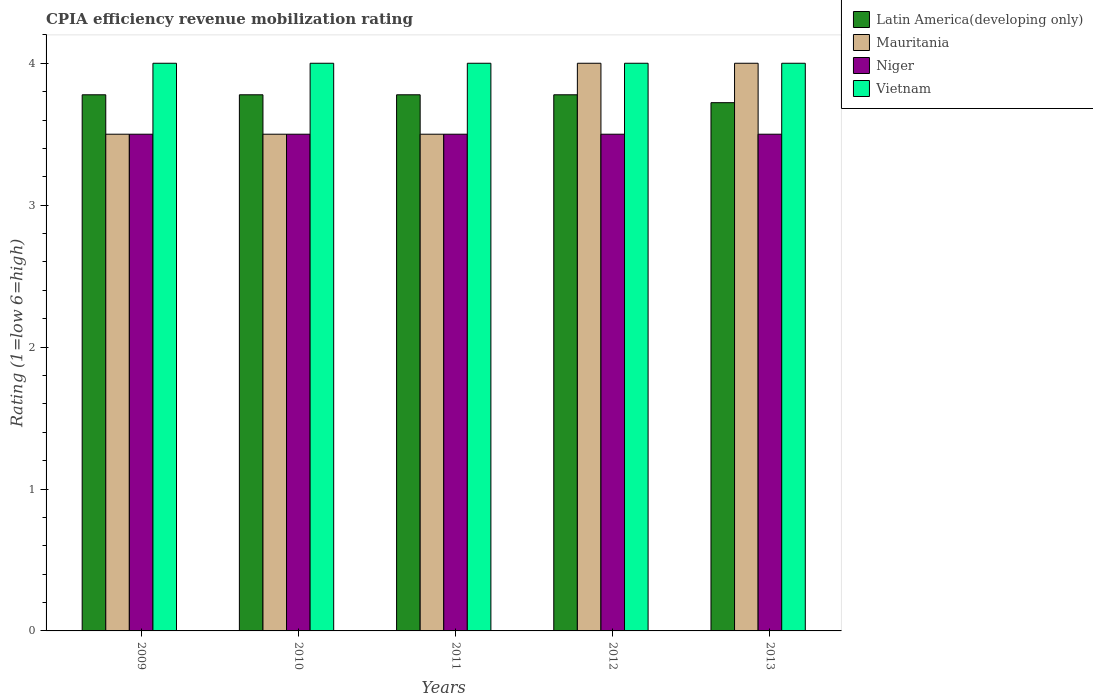How many groups of bars are there?
Your answer should be compact. 5. Are the number of bars on each tick of the X-axis equal?
Offer a terse response. Yes. How many bars are there on the 4th tick from the right?
Give a very brief answer. 4. What is the label of the 1st group of bars from the left?
Give a very brief answer. 2009. In how many cases, is the number of bars for a given year not equal to the number of legend labels?
Provide a succinct answer. 0. What is the CPIA rating in Niger in 2013?
Provide a succinct answer. 3.5. Across all years, what is the maximum CPIA rating in Vietnam?
Offer a terse response. 4. Across all years, what is the minimum CPIA rating in Latin America(developing only)?
Offer a very short reply. 3.72. In which year was the CPIA rating in Mauritania maximum?
Keep it short and to the point. 2012. What is the average CPIA rating in Latin America(developing only) per year?
Provide a short and direct response. 3.77. In the year 2010, what is the difference between the CPIA rating in Mauritania and CPIA rating in Latin America(developing only)?
Offer a terse response. -0.28. What is the ratio of the CPIA rating in Niger in 2009 to that in 2011?
Give a very brief answer. 1. Is the difference between the CPIA rating in Mauritania in 2010 and 2011 greater than the difference between the CPIA rating in Latin America(developing only) in 2010 and 2011?
Keep it short and to the point. No. Is the sum of the CPIA rating in Latin America(developing only) in 2010 and 2012 greater than the maximum CPIA rating in Mauritania across all years?
Ensure brevity in your answer.  Yes. What does the 1st bar from the left in 2013 represents?
Your answer should be very brief. Latin America(developing only). What does the 3rd bar from the right in 2011 represents?
Give a very brief answer. Mauritania. Is it the case that in every year, the sum of the CPIA rating in Latin America(developing only) and CPIA rating in Mauritania is greater than the CPIA rating in Vietnam?
Your answer should be compact. Yes. Are all the bars in the graph horizontal?
Your answer should be compact. No. Where does the legend appear in the graph?
Keep it short and to the point. Top right. What is the title of the graph?
Offer a terse response. CPIA efficiency revenue mobilization rating. Does "Cambodia" appear as one of the legend labels in the graph?
Your answer should be very brief. No. What is the label or title of the X-axis?
Your answer should be very brief. Years. What is the label or title of the Y-axis?
Make the answer very short. Rating (1=low 6=high). What is the Rating (1=low 6=high) in Latin America(developing only) in 2009?
Ensure brevity in your answer.  3.78. What is the Rating (1=low 6=high) of Mauritania in 2009?
Keep it short and to the point. 3.5. What is the Rating (1=low 6=high) of Latin America(developing only) in 2010?
Make the answer very short. 3.78. What is the Rating (1=low 6=high) in Mauritania in 2010?
Offer a very short reply. 3.5. What is the Rating (1=low 6=high) in Latin America(developing only) in 2011?
Give a very brief answer. 3.78. What is the Rating (1=low 6=high) of Vietnam in 2011?
Offer a very short reply. 4. What is the Rating (1=low 6=high) in Latin America(developing only) in 2012?
Offer a terse response. 3.78. What is the Rating (1=low 6=high) of Mauritania in 2012?
Give a very brief answer. 4. What is the Rating (1=low 6=high) in Niger in 2012?
Offer a terse response. 3.5. What is the Rating (1=low 6=high) in Vietnam in 2012?
Provide a short and direct response. 4. What is the Rating (1=low 6=high) of Latin America(developing only) in 2013?
Offer a terse response. 3.72. What is the Rating (1=low 6=high) in Mauritania in 2013?
Make the answer very short. 4. What is the Rating (1=low 6=high) of Vietnam in 2013?
Offer a terse response. 4. Across all years, what is the maximum Rating (1=low 6=high) of Latin America(developing only)?
Your answer should be compact. 3.78. Across all years, what is the maximum Rating (1=low 6=high) in Mauritania?
Ensure brevity in your answer.  4. Across all years, what is the maximum Rating (1=low 6=high) of Niger?
Your answer should be very brief. 3.5. Across all years, what is the maximum Rating (1=low 6=high) of Vietnam?
Keep it short and to the point. 4. Across all years, what is the minimum Rating (1=low 6=high) in Latin America(developing only)?
Give a very brief answer. 3.72. Across all years, what is the minimum Rating (1=low 6=high) in Niger?
Offer a very short reply. 3.5. Across all years, what is the minimum Rating (1=low 6=high) of Vietnam?
Your answer should be compact. 4. What is the total Rating (1=low 6=high) in Latin America(developing only) in the graph?
Your answer should be very brief. 18.83. What is the total Rating (1=low 6=high) in Mauritania in the graph?
Provide a succinct answer. 18.5. What is the total Rating (1=low 6=high) in Niger in the graph?
Your answer should be compact. 17.5. What is the total Rating (1=low 6=high) in Vietnam in the graph?
Keep it short and to the point. 20. What is the difference between the Rating (1=low 6=high) of Mauritania in 2009 and that in 2010?
Keep it short and to the point. 0. What is the difference between the Rating (1=low 6=high) of Vietnam in 2009 and that in 2010?
Offer a terse response. 0. What is the difference between the Rating (1=low 6=high) in Mauritania in 2009 and that in 2012?
Offer a very short reply. -0.5. What is the difference between the Rating (1=low 6=high) of Niger in 2009 and that in 2012?
Your answer should be compact. 0. What is the difference between the Rating (1=low 6=high) in Latin America(developing only) in 2009 and that in 2013?
Offer a very short reply. 0.06. What is the difference between the Rating (1=low 6=high) in Latin America(developing only) in 2010 and that in 2011?
Offer a terse response. 0. What is the difference between the Rating (1=low 6=high) of Niger in 2010 and that in 2011?
Make the answer very short. 0. What is the difference between the Rating (1=low 6=high) of Mauritania in 2010 and that in 2012?
Make the answer very short. -0.5. What is the difference between the Rating (1=low 6=high) of Niger in 2010 and that in 2012?
Ensure brevity in your answer.  0. What is the difference between the Rating (1=low 6=high) in Vietnam in 2010 and that in 2012?
Your answer should be very brief. 0. What is the difference between the Rating (1=low 6=high) of Latin America(developing only) in 2010 and that in 2013?
Provide a succinct answer. 0.06. What is the difference between the Rating (1=low 6=high) of Vietnam in 2010 and that in 2013?
Provide a succinct answer. 0. What is the difference between the Rating (1=low 6=high) of Mauritania in 2011 and that in 2012?
Keep it short and to the point. -0.5. What is the difference between the Rating (1=low 6=high) of Vietnam in 2011 and that in 2012?
Your answer should be very brief. 0. What is the difference between the Rating (1=low 6=high) in Latin America(developing only) in 2011 and that in 2013?
Give a very brief answer. 0.06. What is the difference between the Rating (1=low 6=high) in Niger in 2011 and that in 2013?
Provide a succinct answer. 0. What is the difference between the Rating (1=low 6=high) of Latin America(developing only) in 2012 and that in 2013?
Your answer should be very brief. 0.06. What is the difference between the Rating (1=low 6=high) of Niger in 2012 and that in 2013?
Make the answer very short. 0. What is the difference between the Rating (1=low 6=high) of Latin America(developing only) in 2009 and the Rating (1=low 6=high) of Mauritania in 2010?
Keep it short and to the point. 0.28. What is the difference between the Rating (1=low 6=high) of Latin America(developing only) in 2009 and the Rating (1=low 6=high) of Niger in 2010?
Your response must be concise. 0.28. What is the difference between the Rating (1=low 6=high) in Latin America(developing only) in 2009 and the Rating (1=low 6=high) in Vietnam in 2010?
Offer a terse response. -0.22. What is the difference between the Rating (1=low 6=high) of Mauritania in 2009 and the Rating (1=low 6=high) of Vietnam in 2010?
Your answer should be compact. -0.5. What is the difference between the Rating (1=low 6=high) of Niger in 2009 and the Rating (1=low 6=high) of Vietnam in 2010?
Keep it short and to the point. -0.5. What is the difference between the Rating (1=low 6=high) in Latin America(developing only) in 2009 and the Rating (1=low 6=high) in Mauritania in 2011?
Keep it short and to the point. 0.28. What is the difference between the Rating (1=low 6=high) of Latin America(developing only) in 2009 and the Rating (1=low 6=high) of Niger in 2011?
Give a very brief answer. 0.28. What is the difference between the Rating (1=low 6=high) of Latin America(developing only) in 2009 and the Rating (1=low 6=high) of Vietnam in 2011?
Make the answer very short. -0.22. What is the difference between the Rating (1=low 6=high) in Niger in 2009 and the Rating (1=low 6=high) in Vietnam in 2011?
Your answer should be compact. -0.5. What is the difference between the Rating (1=low 6=high) in Latin America(developing only) in 2009 and the Rating (1=low 6=high) in Mauritania in 2012?
Offer a terse response. -0.22. What is the difference between the Rating (1=low 6=high) of Latin America(developing only) in 2009 and the Rating (1=low 6=high) of Niger in 2012?
Make the answer very short. 0.28. What is the difference between the Rating (1=low 6=high) of Latin America(developing only) in 2009 and the Rating (1=low 6=high) of Vietnam in 2012?
Make the answer very short. -0.22. What is the difference between the Rating (1=low 6=high) of Mauritania in 2009 and the Rating (1=low 6=high) of Vietnam in 2012?
Your answer should be compact. -0.5. What is the difference between the Rating (1=low 6=high) of Latin America(developing only) in 2009 and the Rating (1=low 6=high) of Mauritania in 2013?
Your answer should be very brief. -0.22. What is the difference between the Rating (1=low 6=high) in Latin America(developing only) in 2009 and the Rating (1=low 6=high) in Niger in 2013?
Give a very brief answer. 0.28. What is the difference between the Rating (1=low 6=high) in Latin America(developing only) in 2009 and the Rating (1=low 6=high) in Vietnam in 2013?
Provide a short and direct response. -0.22. What is the difference between the Rating (1=low 6=high) in Mauritania in 2009 and the Rating (1=low 6=high) in Niger in 2013?
Provide a succinct answer. 0. What is the difference between the Rating (1=low 6=high) in Mauritania in 2009 and the Rating (1=low 6=high) in Vietnam in 2013?
Your answer should be very brief. -0.5. What is the difference between the Rating (1=low 6=high) of Niger in 2009 and the Rating (1=low 6=high) of Vietnam in 2013?
Offer a terse response. -0.5. What is the difference between the Rating (1=low 6=high) of Latin America(developing only) in 2010 and the Rating (1=low 6=high) of Mauritania in 2011?
Provide a short and direct response. 0.28. What is the difference between the Rating (1=low 6=high) of Latin America(developing only) in 2010 and the Rating (1=low 6=high) of Niger in 2011?
Ensure brevity in your answer.  0.28. What is the difference between the Rating (1=low 6=high) in Latin America(developing only) in 2010 and the Rating (1=low 6=high) in Vietnam in 2011?
Offer a terse response. -0.22. What is the difference between the Rating (1=low 6=high) of Mauritania in 2010 and the Rating (1=low 6=high) of Niger in 2011?
Offer a terse response. 0. What is the difference between the Rating (1=low 6=high) in Mauritania in 2010 and the Rating (1=low 6=high) in Vietnam in 2011?
Offer a very short reply. -0.5. What is the difference between the Rating (1=low 6=high) of Latin America(developing only) in 2010 and the Rating (1=low 6=high) of Mauritania in 2012?
Offer a very short reply. -0.22. What is the difference between the Rating (1=low 6=high) in Latin America(developing only) in 2010 and the Rating (1=low 6=high) in Niger in 2012?
Offer a terse response. 0.28. What is the difference between the Rating (1=low 6=high) of Latin America(developing only) in 2010 and the Rating (1=low 6=high) of Vietnam in 2012?
Ensure brevity in your answer.  -0.22. What is the difference between the Rating (1=low 6=high) of Mauritania in 2010 and the Rating (1=low 6=high) of Vietnam in 2012?
Your response must be concise. -0.5. What is the difference between the Rating (1=low 6=high) of Niger in 2010 and the Rating (1=low 6=high) of Vietnam in 2012?
Keep it short and to the point. -0.5. What is the difference between the Rating (1=low 6=high) in Latin America(developing only) in 2010 and the Rating (1=low 6=high) in Mauritania in 2013?
Provide a succinct answer. -0.22. What is the difference between the Rating (1=low 6=high) of Latin America(developing only) in 2010 and the Rating (1=low 6=high) of Niger in 2013?
Your response must be concise. 0.28. What is the difference between the Rating (1=low 6=high) of Latin America(developing only) in 2010 and the Rating (1=low 6=high) of Vietnam in 2013?
Your response must be concise. -0.22. What is the difference between the Rating (1=low 6=high) of Mauritania in 2010 and the Rating (1=low 6=high) of Niger in 2013?
Your response must be concise. 0. What is the difference between the Rating (1=low 6=high) of Mauritania in 2010 and the Rating (1=low 6=high) of Vietnam in 2013?
Ensure brevity in your answer.  -0.5. What is the difference between the Rating (1=low 6=high) of Latin America(developing only) in 2011 and the Rating (1=low 6=high) of Mauritania in 2012?
Keep it short and to the point. -0.22. What is the difference between the Rating (1=low 6=high) of Latin America(developing only) in 2011 and the Rating (1=low 6=high) of Niger in 2012?
Your answer should be very brief. 0.28. What is the difference between the Rating (1=low 6=high) of Latin America(developing only) in 2011 and the Rating (1=low 6=high) of Vietnam in 2012?
Offer a terse response. -0.22. What is the difference between the Rating (1=low 6=high) of Mauritania in 2011 and the Rating (1=low 6=high) of Niger in 2012?
Your answer should be compact. 0. What is the difference between the Rating (1=low 6=high) of Mauritania in 2011 and the Rating (1=low 6=high) of Vietnam in 2012?
Your response must be concise. -0.5. What is the difference between the Rating (1=low 6=high) of Latin America(developing only) in 2011 and the Rating (1=low 6=high) of Mauritania in 2013?
Make the answer very short. -0.22. What is the difference between the Rating (1=low 6=high) of Latin America(developing only) in 2011 and the Rating (1=low 6=high) of Niger in 2013?
Your response must be concise. 0.28. What is the difference between the Rating (1=low 6=high) in Latin America(developing only) in 2011 and the Rating (1=low 6=high) in Vietnam in 2013?
Your answer should be compact. -0.22. What is the difference between the Rating (1=low 6=high) of Mauritania in 2011 and the Rating (1=low 6=high) of Niger in 2013?
Ensure brevity in your answer.  0. What is the difference between the Rating (1=low 6=high) in Latin America(developing only) in 2012 and the Rating (1=low 6=high) in Mauritania in 2013?
Your answer should be compact. -0.22. What is the difference between the Rating (1=low 6=high) in Latin America(developing only) in 2012 and the Rating (1=low 6=high) in Niger in 2013?
Provide a succinct answer. 0.28. What is the difference between the Rating (1=low 6=high) of Latin America(developing only) in 2012 and the Rating (1=low 6=high) of Vietnam in 2013?
Give a very brief answer. -0.22. What is the average Rating (1=low 6=high) of Latin America(developing only) per year?
Offer a very short reply. 3.77. What is the average Rating (1=low 6=high) of Niger per year?
Offer a very short reply. 3.5. In the year 2009, what is the difference between the Rating (1=low 6=high) of Latin America(developing only) and Rating (1=low 6=high) of Mauritania?
Your answer should be compact. 0.28. In the year 2009, what is the difference between the Rating (1=low 6=high) of Latin America(developing only) and Rating (1=low 6=high) of Niger?
Your answer should be compact. 0.28. In the year 2009, what is the difference between the Rating (1=low 6=high) in Latin America(developing only) and Rating (1=low 6=high) in Vietnam?
Your answer should be very brief. -0.22. In the year 2009, what is the difference between the Rating (1=low 6=high) of Mauritania and Rating (1=low 6=high) of Vietnam?
Offer a terse response. -0.5. In the year 2009, what is the difference between the Rating (1=low 6=high) of Niger and Rating (1=low 6=high) of Vietnam?
Provide a short and direct response. -0.5. In the year 2010, what is the difference between the Rating (1=low 6=high) of Latin America(developing only) and Rating (1=low 6=high) of Mauritania?
Make the answer very short. 0.28. In the year 2010, what is the difference between the Rating (1=low 6=high) in Latin America(developing only) and Rating (1=low 6=high) in Niger?
Give a very brief answer. 0.28. In the year 2010, what is the difference between the Rating (1=low 6=high) of Latin America(developing only) and Rating (1=low 6=high) of Vietnam?
Give a very brief answer. -0.22. In the year 2010, what is the difference between the Rating (1=low 6=high) of Mauritania and Rating (1=low 6=high) of Vietnam?
Your response must be concise. -0.5. In the year 2010, what is the difference between the Rating (1=low 6=high) of Niger and Rating (1=low 6=high) of Vietnam?
Make the answer very short. -0.5. In the year 2011, what is the difference between the Rating (1=low 6=high) of Latin America(developing only) and Rating (1=low 6=high) of Mauritania?
Your answer should be very brief. 0.28. In the year 2011, what is the difference between the Rating (1=low 6=high) in Latin America(developing only) and Rating (1=low 6=high) in Niger?
Offer a terse response. 0.28. In the year 2011, what is the difference between the Rating (1=low 6=high) of Latin America(developing only) and Rating (1=low 6=high) of Vietnam?
Provide a short and direct response. -0.22. In the year 2011, what is the difference between the Rating (1=low 6=high) in Mauritania and Rating (1=low 6=high) in Vietnam?
Offer a very short reply. -0.5. In the year 2012, what is the difference between the Rating (1=low 6=high) in Latin America(developing only) and Rating (1=low 6=high) in Mauritania?
Your answer should be very brief. -0.22. In the year 2012, what is the difference between the Rating (1=low 6=high) in Latin America(developing only) and Rating (1=low 6=high) in Niger?
Your response must be concise. 0.28. In the year 2012, what is the difference between the Rating (1=low 6=high) of Latin America(developing only) and Rating (1=low 6=high) of Vietnam?
Your answer should be compact. -0.22. In the year 2013, what is the difference between the Rating (1=low 6=high) of Latin America(developing only) and Rating (1=low 6=high) of Mauritania?
Your answer should be compact. -0.28. In the year 2013, what is the difference between the Rating (1=low 6=high) in Latin America(developing only) and Rating (1=low 6=high) in Niger?
Your answer should be compact. 0.22. In the year 2013, what is the difference between the Rating (1=low 6=high) in Latin America(developing only) and Rating (1=low 6=high) in Vietnam?
Provide a succinct answer. -0.28. In the year 2013, what is the difference between the Rating (1=low 6=high) in Mauritania and Rating (1=low 6=high) in Vietnam?
Ensure brevity in your answer.  0. In the year 2013, what is the difference between the Rating (1=low 6=high) of Niger and Rating (1=low 6=high) of Vietnam?
Provide a short and direct response. -0.5. What is the ratio of the Rating (1=low 6=high) of Niger in 2009 to that in 2010?
Give a very brief answer. 1. What is the ratio of the Rating (1=low 6=high) in Latin America(developing only) in 2009 to that in 2011?
Make the answer very short. 1. What is the ratio of the Rating (1=low 6=high) of Latin America(developing only) in 2009 to that in 2012?
Your answer should be compact. 1. What is the ratio of the Rating (1=low 6=high) in Mauritania in 2009 to that in 2012?
Provide a short and direct response. 0.88. What is the ratio of the Rating (1=low 6=high) in Niger in 2009 to that in 2012?
Make the answer very short. 1. What is the ratio of the Rating (1=low 6=high) in Vietnam in 2009 to that in 2012?
Ensure brevity in your answer.  1. What is the ratio of the Rating (1=low 6=high) of Latin America(developing only) in 2009 to that in 2013?
Your answer should be very brief. 1.01. What is the ratio of the Rating (1=low 6=high) in Mauritania in 2009 to that in 2013?
Your answer should be very brief. 0.88. What is the ratio of the Rating (1=low 6=high) in Mauritania in 2010 to that in 2011?
Your response must be concise. 1. What is the ratio of the Rating (1=low 6=high) of Niger in 2010 to that in 2011?
Offer a very short reply. 1. What is the ratio of the Rating (1=low 6=high) of Vietnam in 2010 to that in 2012?
Make the answer very short. 1. What is the ratio of the Rating (1=low 6=high) of Latin America(developing only) in 2010 to that in 2013?
Your response must be concise. 1.01. What is the ratio of the Rating (1=low 6=high) in Mauritania in 2010 to that in 2013?
Make the answer very short. 0.88. What is the ratio of the Rating (1=low 6=high) of Vietnam in 2010 to that in 2013?
Offer a very short reply. 1. What is the ratio of the Rating (1=low 6=high) in Latin America(developing only) in 2011 to that in 2012?
Give a very brief answer. 1. What is the ratio of the Rating (1=low 6=high) in Niger in 2011 to that in 2012?
Provide a succinct answer. 1. What is the ratio of the Rating (1=low 6=high) of Vietnam in 2011 to that in 2012?
Your response must be concise. 1. What is the ratio of the Rating (1=low 6=high) of Latin America(developing only) in 2011 to that in 2013?
Give a very brief answer. 1.01. What is the ratio of the Rating (1=low 6=high) of Niger in 2011 to that in 2013?
Make the answer very short. 1. What is the ratio of the Rating (1=low 6=high) in Vietnam in 2011 to that in 2013?
Give a very brief answer. 1. What is the ratio of the Rating (1=low 6=high) in Latin America(developing only) in 2012 to that in 2013?
Your answer should be very brief. 1.01. What is the ratio of the Rating (1=low 6=high) in Mauritania in 2012 to that in 2013?
Your response must be concise. 1. What is the ratio of the Rating (1=low 6=high) of Niger in 2012 to that in 2013?
Provide a succinct answer. 1. What is the ratio of the Rating (1=low 6=high) in Vietnam in 2012 to that in 2013?
Provide a succinct answer. 1. What is the difference between the highest and the second highest Rating (1=low 6=high) in Latin America(developing only)?
Your response must be concise. 0. What is the difference between the highest and the second highest Rating (1=low 6=high) of Mauritania?
Make the answer very short. 0. What is the difference between the highest and the second highest Rating (1=low 6=high) in Niger?
Provide a succinct answer. 0. What is the difference between the highest and the second highest Rating (1=low 6=high) in Vietnam?
Give a very brief answer. 0. What is the difference between the highest and the lowest Rating (1=low 6=high) in Latin America(developing only)?
Provide a short and direct response. 0.06. What is the difference between the highest and the lowest Rating (1=low 6=high) in Niger?
Provide a succinct answer. 0. 